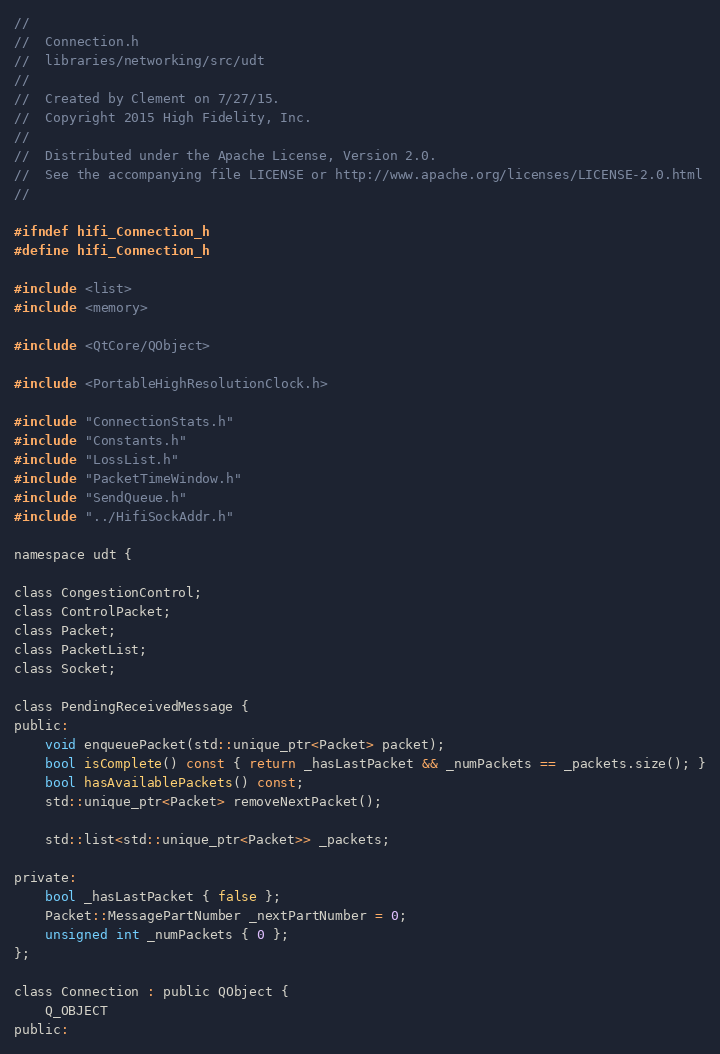<code> <loc_0><loc_0><loc_500><loc_500><_C_>//
//  Connection.h
//  libraries/networking/src/udt
//
//  Created by Clement on 7/27/15.
//  Copyright 2015 High Fidelity, Inc.
//
//  Distributed under the Apache License, Version 2.0.
//  See the accompanying file LICENSE or http://www.apache.org/licenses/LICENSE-2.0.html
//

#ifndef hifi_Connection_h
#define hifi_Connection_h

#include <list>
#include <memory>

#include <QtCore/QObject>

#include <PortableHighResolutionClock.h>

#include "ConnectionStats.h"
#include "Constants.h"
#include "LossList.h"
#include "PacketTimeWindow.h"
#include "SendQueue.h"
#include "../HifiSockAddr.h"

namespace udt {
    
class CongestionControl;
class ControlPacket;
class Packet;
class PacketList;
class Socket;

class PendingReceivedMessage {
public:
    void enqueuePacket(std::unique_ptr<Packet> packet);
    bool isComplete() const { return _hasLastPacket && _numPackets == _packets.size(); }
    bool hasAvailablePackets() const;
    std::unique_ptr<Packet> removeNextPacket();
    
    std::list<std::unique_ptr<Packet>> _packets;

private:
    bool _hasLastPacket { false };
    Packet::MessagePartNumber _nextPartNumber = 0;
    unsigned int _numPackets { 0 };
};

class Connection : public QObject {
    Q_OBJECT
public:</code> 